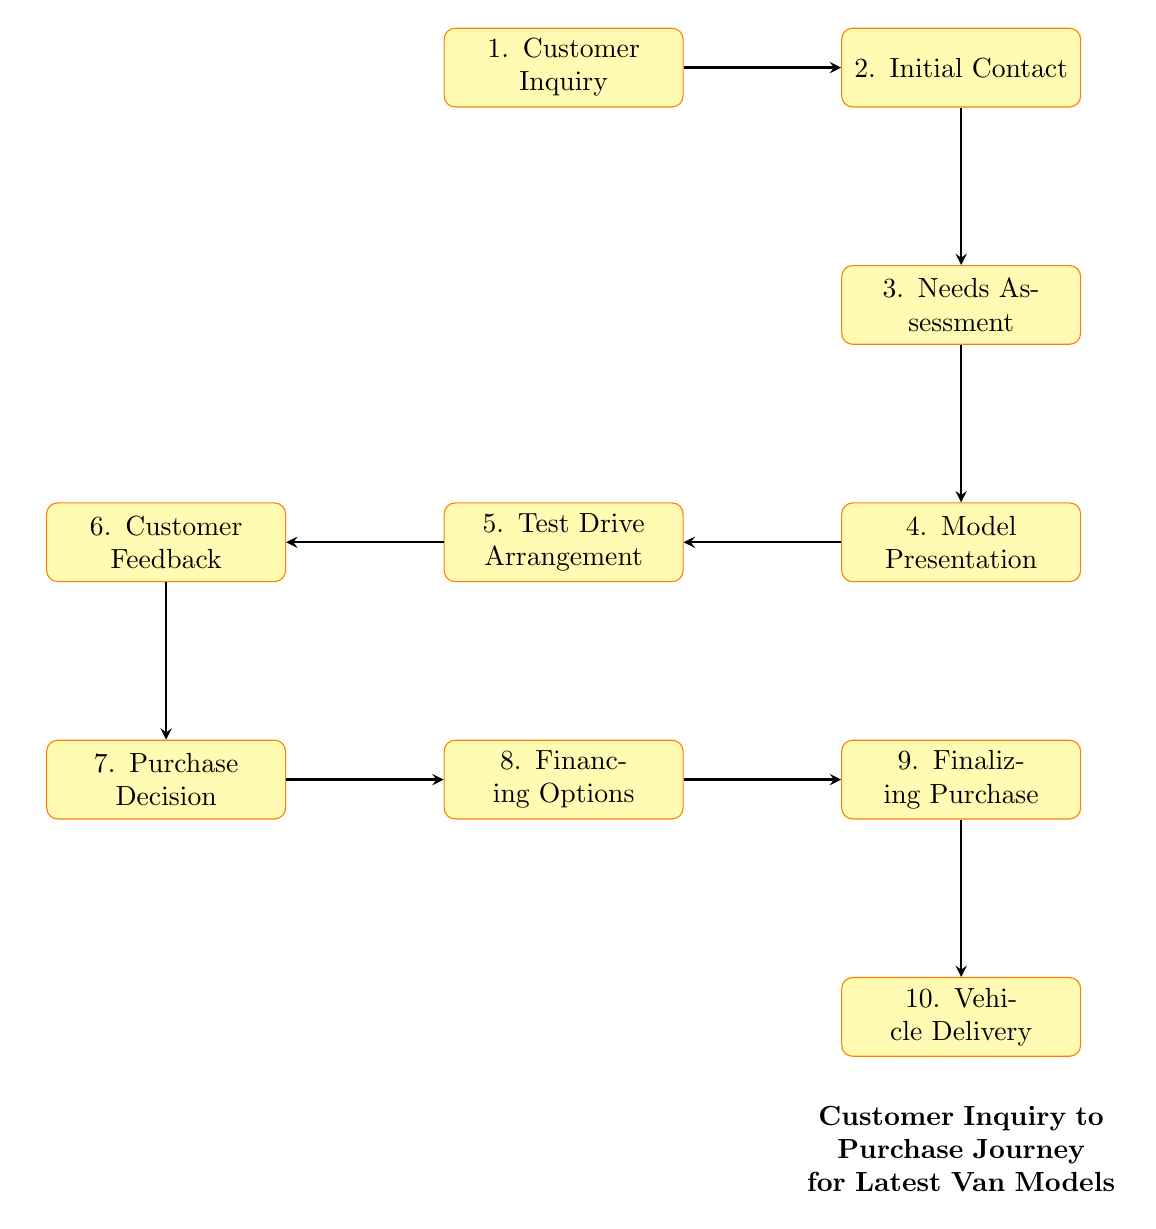What is the first step in the customer journey? The diagram starts with the first node labeled "Customer Inquiry," indicating that the journey begins with the potential customer making an inquiry about the latest van models.
Answer: Customer Inquiry How many total steps are there in the journey? By counting the nodes in the diagram, there are ten distinct steps that the customer goes through, from inquiry to vehicle delivery.
Answer: Ten Which node follows the "Needs Assessment"? In the diagram, the "Needs Assessment" node is directly followed by the "Model Presentation" node, indicating that after assessing needs, the dealer presents suitable models.
Answer: Model Presentation What does the customer provide after the test drive? The node labeled "Customer Feedback" indicates that the customer provides feedback after experiencing the test drive of the van models.
Answer: Customer Feedback Which step occurs after the "Purchase Decision"? Following the "Purchase Decision" node, the next step in the journey is the "Financing Options," where the dealer provides information on payment options.
Answer: Financing Options What is the relationship between "Test Drive Arrangement" and "Customer Feedback"? The relationship shows a sequential flow where "Test Drive Arrangement" leads to "Customer Feedback," indicating that feedback is given after a test drive is arranged and completed.
Answer: Sequential flow Which step directly precedes the “Vehicle Delivery”? The “Finalizing Purchase” step directly precedes the “Vehicle Delivery” in the diagram, indicating that the purchase must be finalized before the van is delivered.
Answer: Finalizing Purchase What action takes place after the dealer responds to the inquiry? The action that follows is the “Needs Assessment,” where the dealer assesses the customer's specific needs and preferences after initial contact.
Answer: Needs Assessment How does the flow chart illustrate the progression from inquiry to delivery? The flow chart uses a sequence of interconnected nodes to represent each step of the journey, showing how one action leads to the next, culminating in the delivery of the vehicle.
Answer: Interconnected nodes What is noted after the "Model Presentation"? After "Model Presentation," the next noted step is "Test Drive Arrangement," indicating that a test drive is organized following the presentation of van models.
Answer: Test Drive Arrangement 